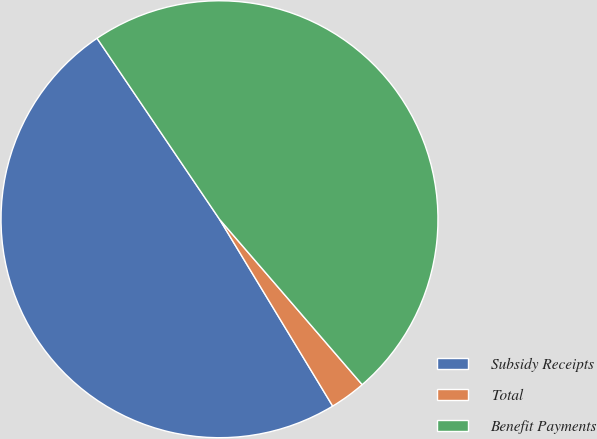<chart> <loc_0><loc_0><loc_500><loc_500><pie_chart><fcel>Subsidy Receipts<fcel>Total<fcel>Benefit Payments<nl><fcel>49.2%<fcel>2.66%<fcel>48.14%<nl></chart> 